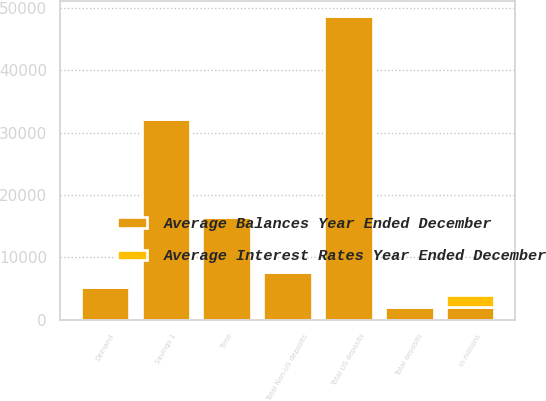Convert chart. <chart><loc_0><loc_0><loc_500><loc_500><stacked_bar_chart><ecel><fcel>in millions<fcel>Savings 1<fcel>Time<fcel>Total US deposits<fcel>Demand<fcel>Total Non-US deposits<fcel>Total deposits<nl><fcel>Average Balances Year Ended December<fcel>2012<fcel>32235<fcel>16433<fcel>48668<fcel>5318<fcel>7731<fcel>2012<nl><fcel>Average Interest Rates Year Ended December<fcel>2012<fcel>0.42<fcel>1.38<fcel>0.74<fcel>0.3<fcel>0.48<fcel>0.71<nl></chart> 